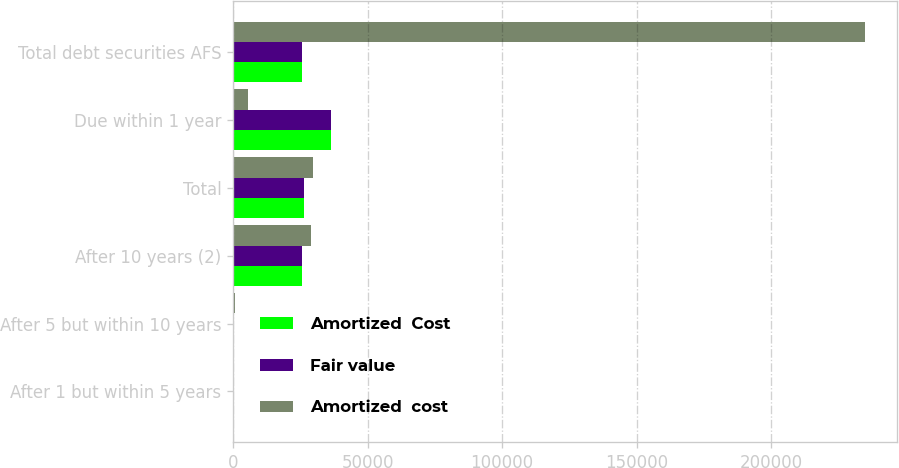Convert chart. <chart><loc_0><loc_0><loc_500><loc_500><stacked_bar_chart><ecel><fcel>After 1 but within 5 years<fcel>After 5 but within 10 years<fcel>After 10 years (2)<fcel>Total<fcel>Due within 1 year<fcel>Total debt securities AFS<nl><fcel>Amortized  Cost<fcel>403<fcel>402<fcel>25685<fcel>26490<fcel>36411<fcel>25698.5<nl><fcel>Fair value<fcel>375<fcel>419<fcel>25712<fcel>26506<fcel>36443<fcel>25698.5<nl><fcel>Amortized  cost<fcel>16<fcel>626<fcel>28952<fcel>29596<fcel>5357<fcel>235123<nl></chart> 